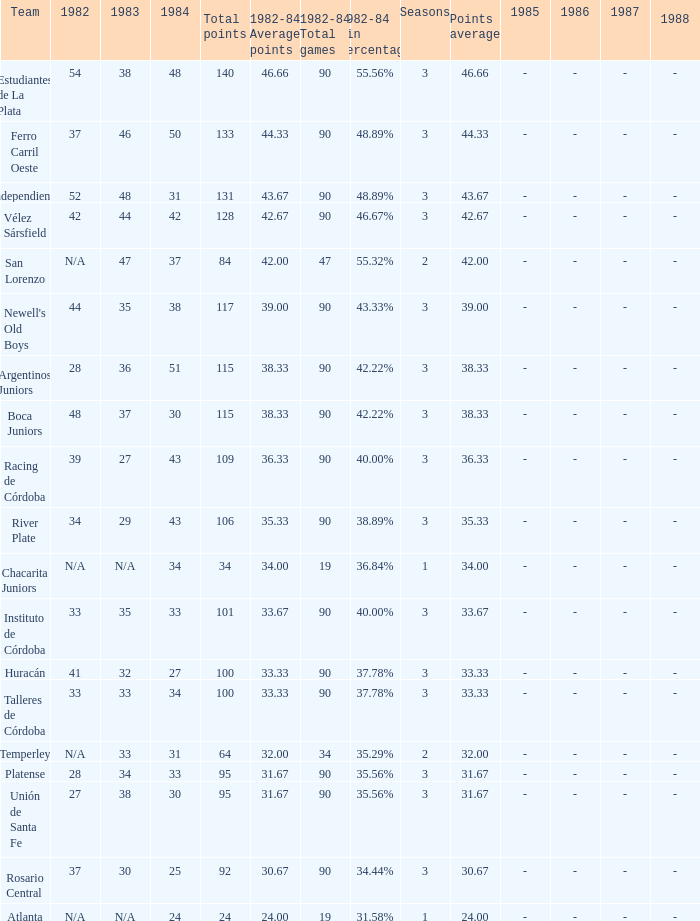What team had 3 seasons and fewer than 27 in 1984? Rosario Central. 